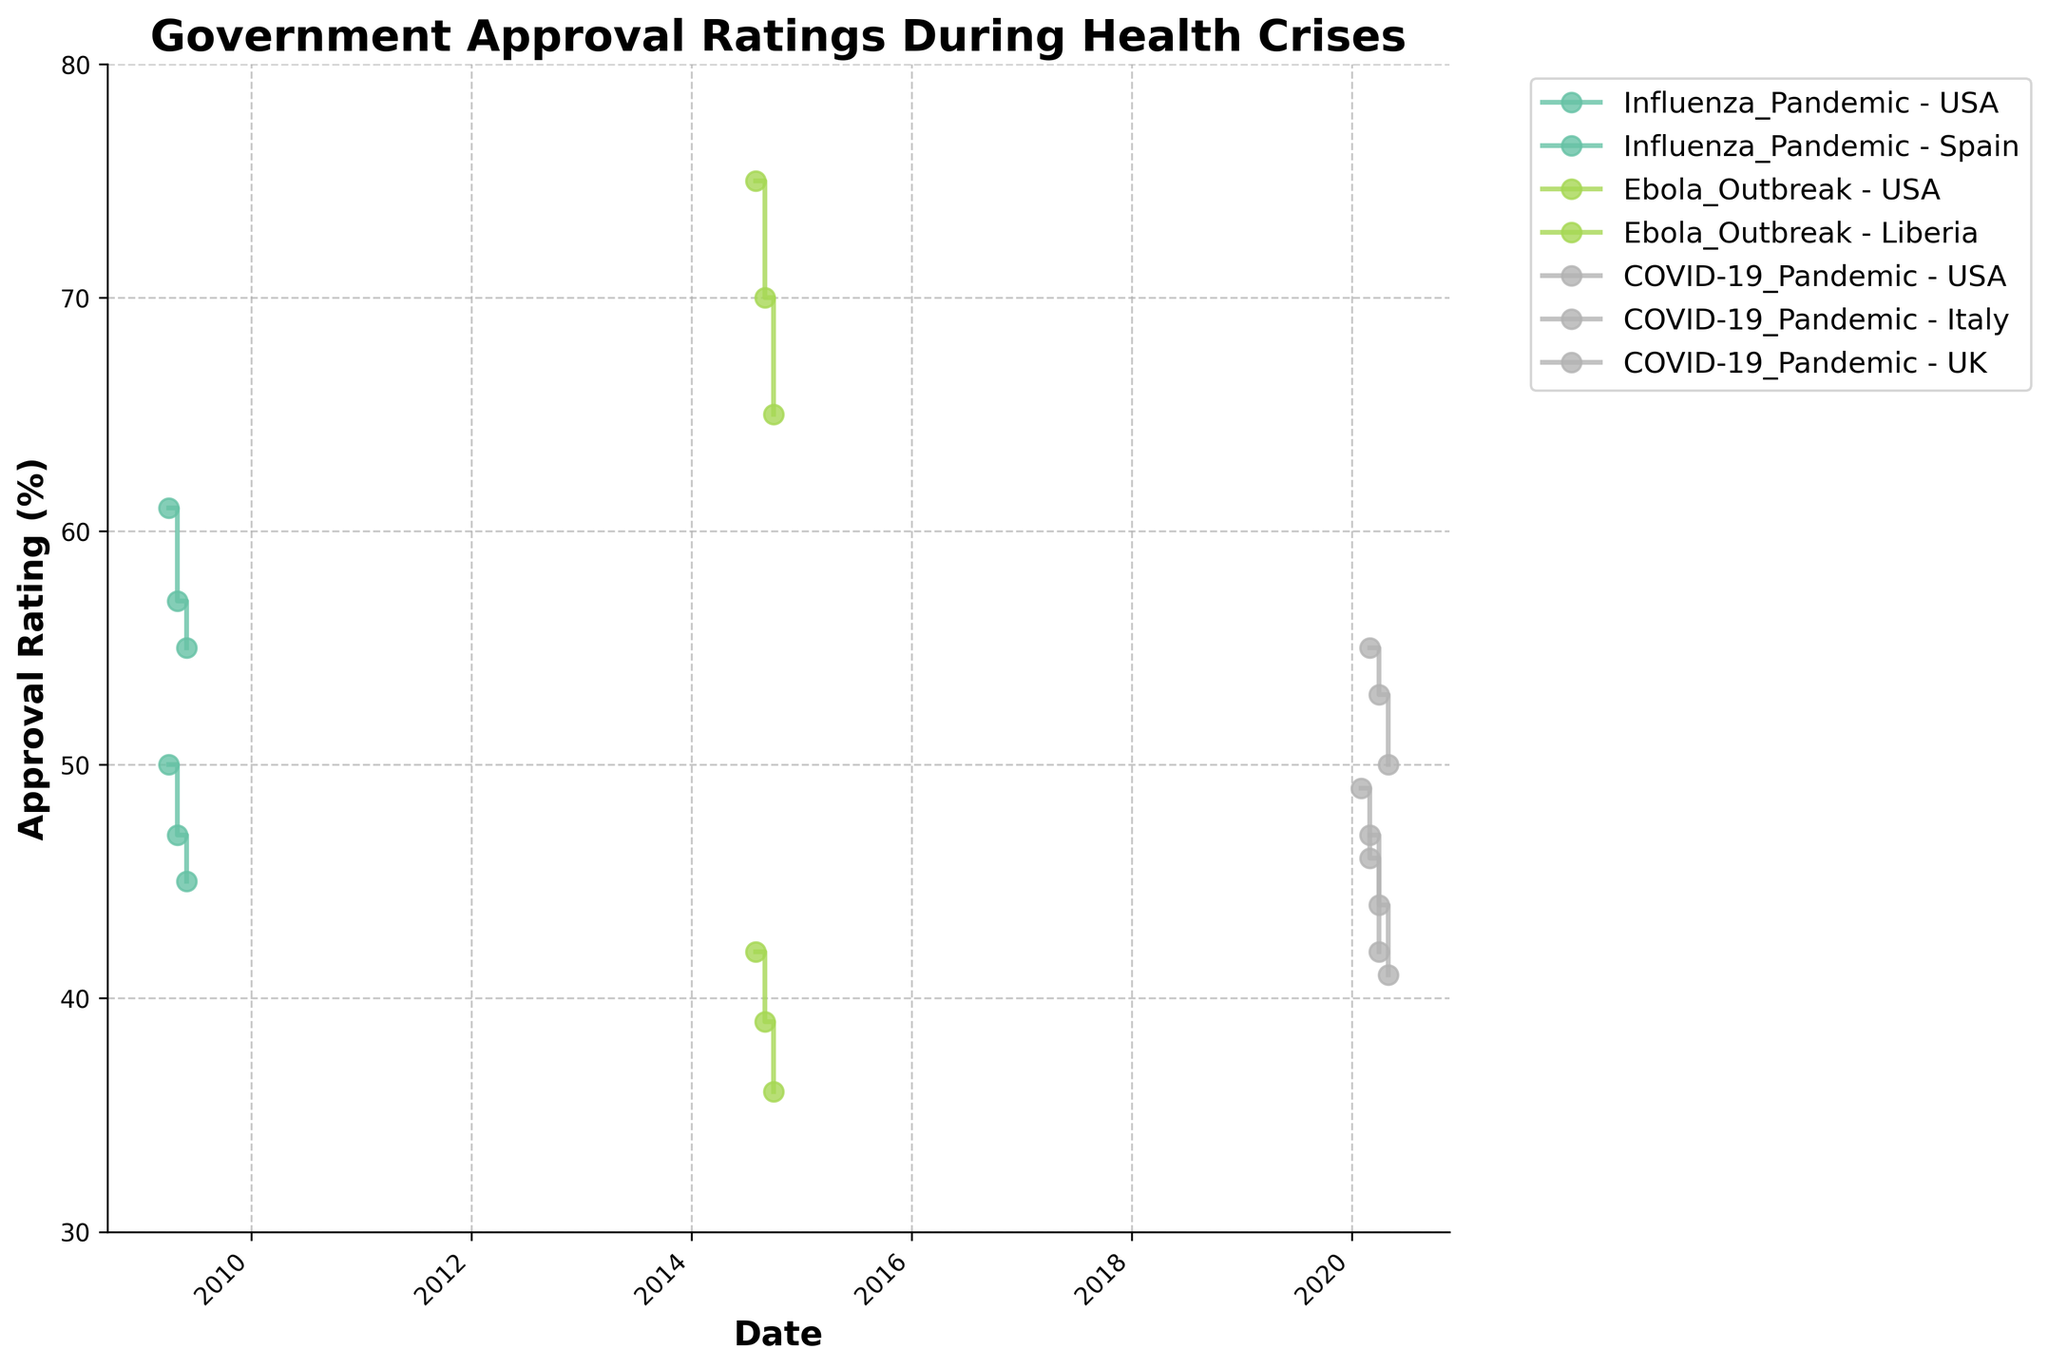What is the title of the figure? The title of the figure is prominently displayed at the top and provides an overview of the content of the chart. Here, the title "Government Approval Ratings During Health Crises" summarizes what the chart illustrates.
Answer: Government Approval Ratings During Health Crises What is the general trend in the approval rating during the COVID-19 pandemic in the USA? To identify the trend, observe the line marked for the USA during the COVID-19 pandemic. The approval rating starts at 47 in March 2020, then decreases to 44 in April, and further falls to 41 in May. This indicates a downward trend.
Answer: Downward Which country had the highest approval rating during the Ebola Outbreak? The approval ratings during the Ebola Outbreak are shown for the USA and Liberia. Liberia’s ratings are 75, 70, and 65, whereas the USA's are 42, 39, and 36. The highest of these is 75 in Liberia.
Answer: Liberia What was the difference in the approval rating in Spain during the Influenza Pandemic between April and June 2009? For Spain during the Influenza Pandemic, the approval ratings in April, May, and June 2009 are 50, 47, and 45, respectively. The difference between April and June is calculated as 50 - 45 = 5.
Answer: 5 Compare the approval ratings of the UK and Italy during the COVID-19 pandemic in April 2020. Which country had a higher rating and by how much? The approval ratings for April 2020 are 53 for the UK and 42 for Italy. To find the difference, subtract Italy's rating from the UK's rating: 53 - 42 = 11. The UK had a higher rating by 11 points.
Answer: UK by 11 points What is the average approval rating in the USA during the COVID-19 pandemic based on the available data points? The approval ratings in the USA during the COVID-19 pandemic are 47 in March, 44 in April, and 41 in May 2020. The average is calculated by summing these and dividing by the number of points: (47 + 44 + 41) / 3 = 44.
Answer: 44 Which crisis type had the steepest decline in approval ratings for the USA, and what is the amount of the decline? The approval ratings for the USA during the Influenza Pandemic dropped from 61 to 55, a decline of 6 points. During the Ebola Outbreak, the drop was from 42 to 36, a decline of 6 points. During COVID-19, the drop was from 47 to 41, a decline of 6 points. Therefore, the steepest decline for the USA is equally 6 points for all the crisis types.
Answer: Each crisis: 6 points Among the countries represented, which country's approval ratings dropped the most during any of the crises depicted? Assessing each country's approval ratings, Liberia during the Ebola Outbreak dropped from 75 to 65, which is a 10-point decline. This is the largest single-country decline shown.
Answer: Liberia What patterns can be observed in Spain's government approval rating during the Influenza Pandemic in 2009? Spain's approval ratings during the Influenza Pandemic were 50 in April, then dropped to 47 in May, and further to 45 in June, showing a consistent downward pattern each month.
Answer: Consistent downward pattern 